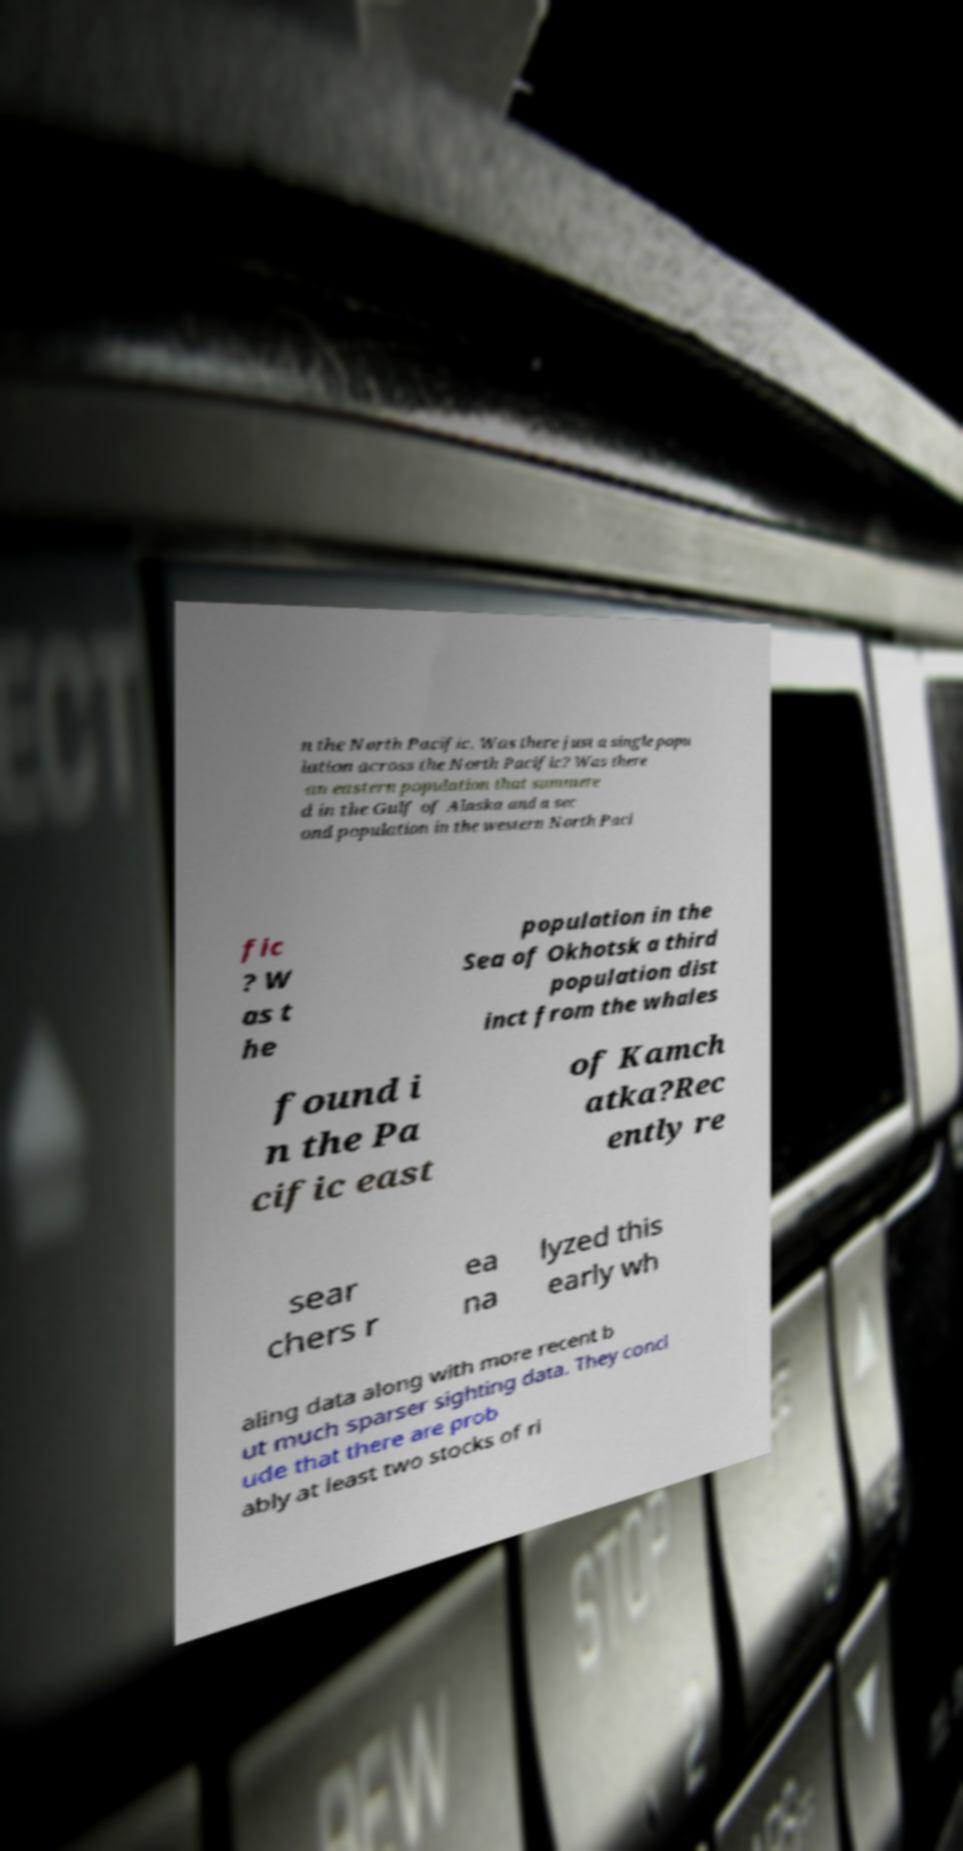There's text embedded in this image that I need extracted. Can you transcribe it verbatim? n the North Pacific. Was there just a single popu lation across the North Pacific? Was there an eastern population that summere d in the Gulf of Alaska and a sec ond population in the western North Paci fic ? W as t he population in the Sea of Okhotsk a third population dist inct from the whales found i n the Pa cific east of Kamch atka?Rec ently re sear chers r ea na lyzed this early wh aling data along with more recent b ut much sparser sighting data. They concl ude that there are prob ably at least two stocks of ri 